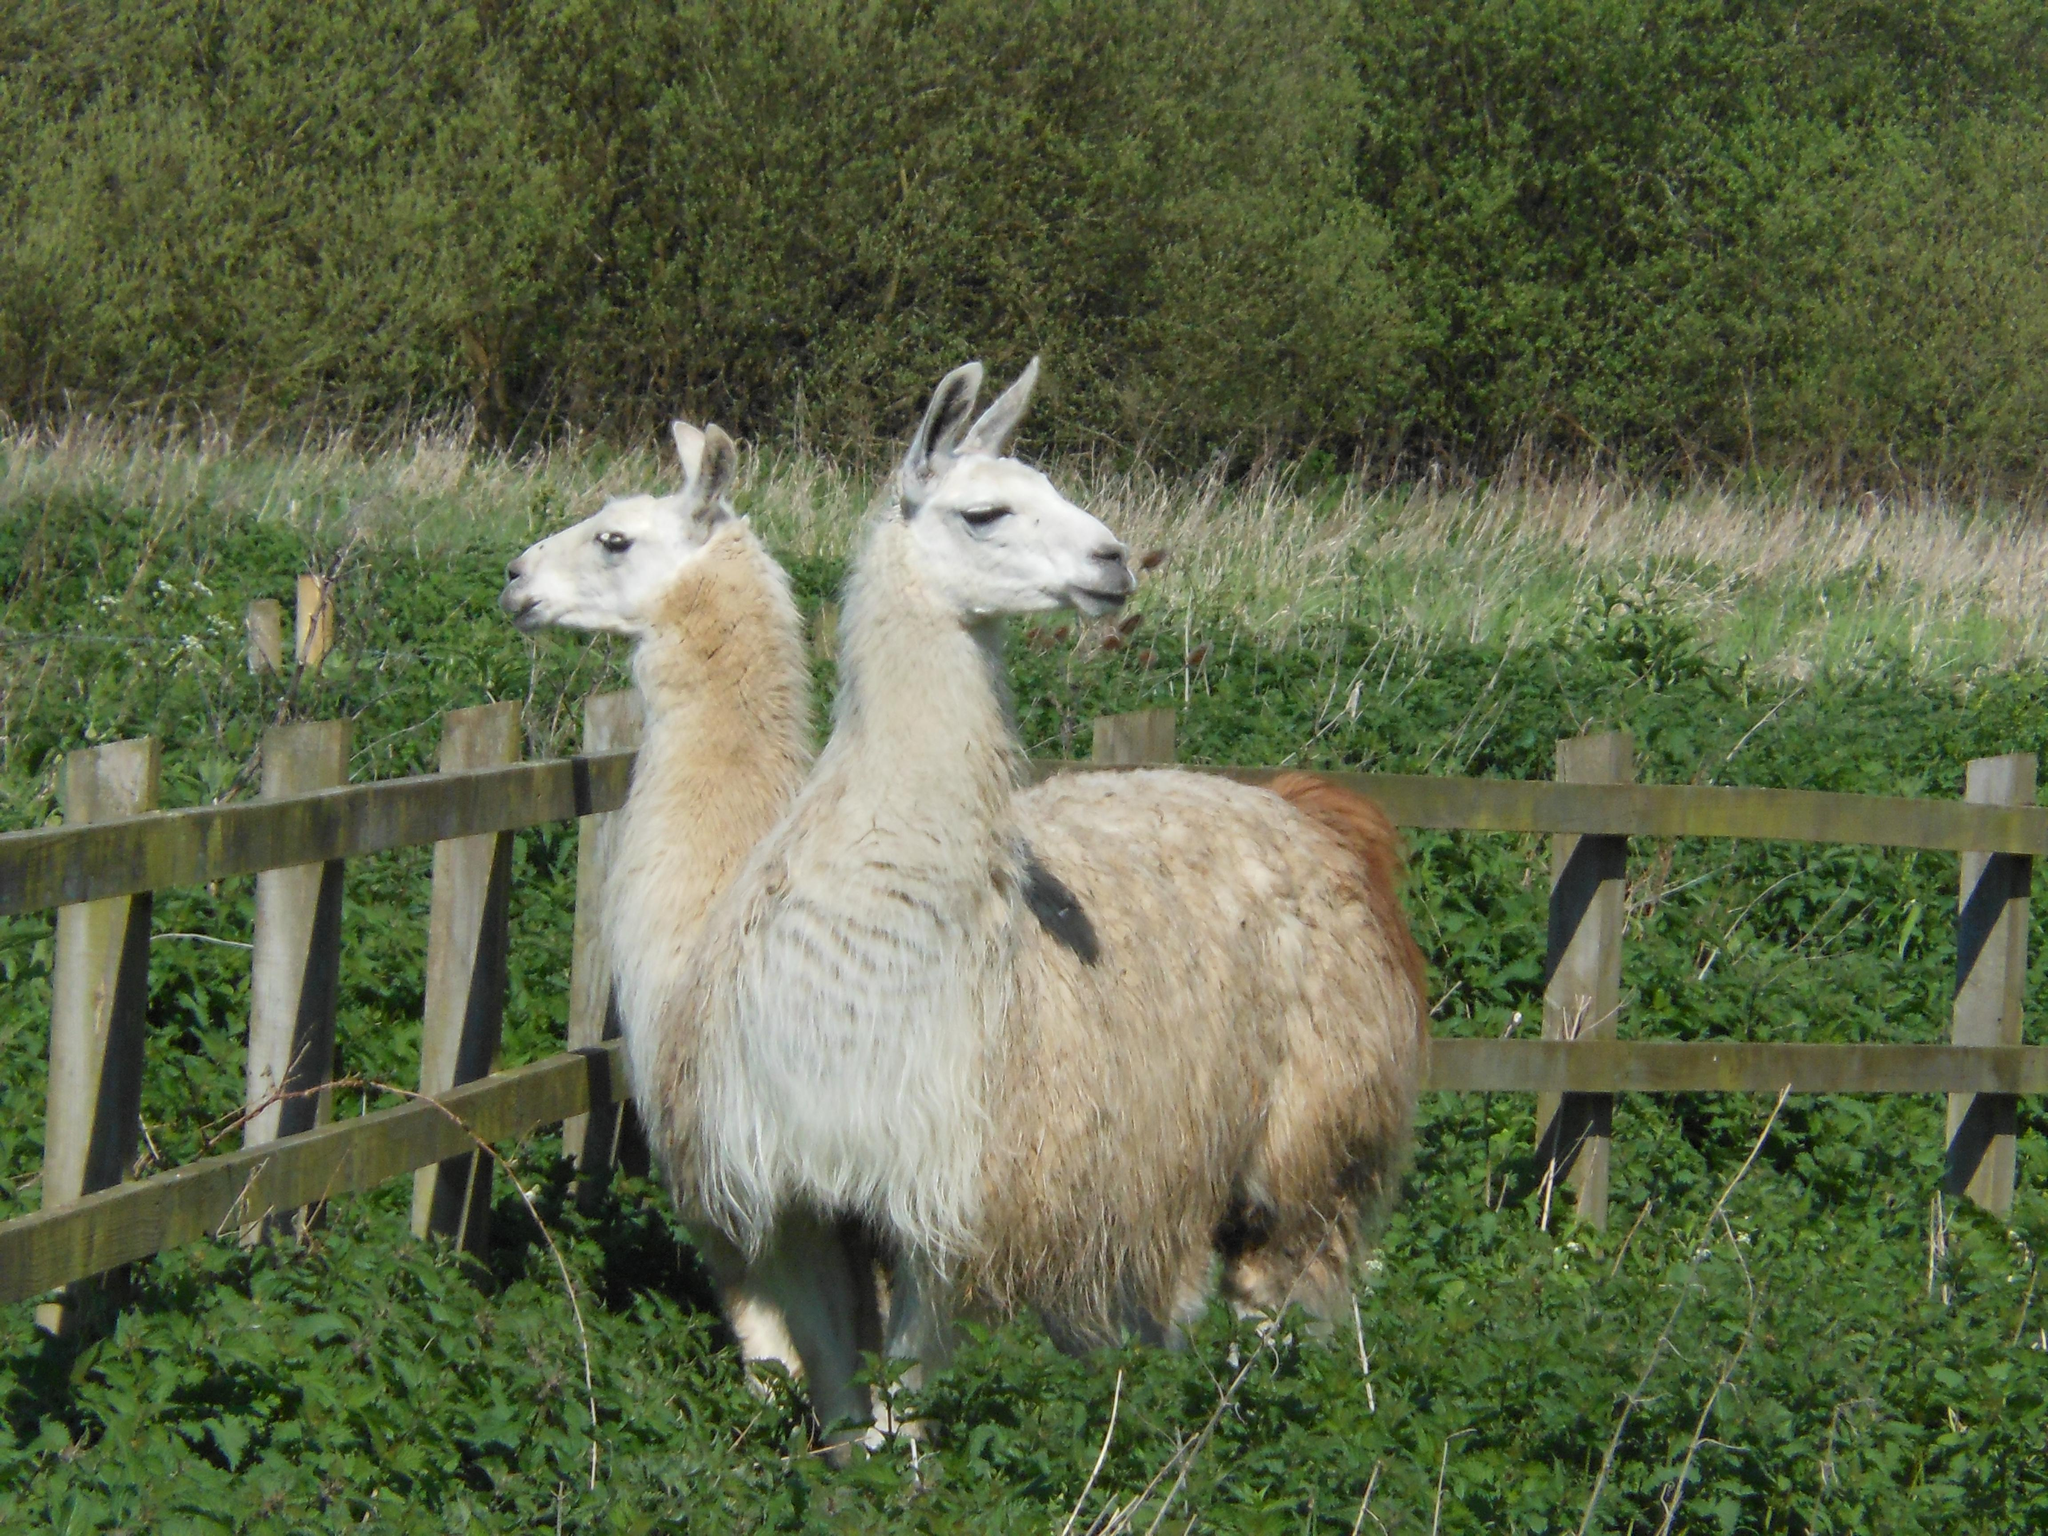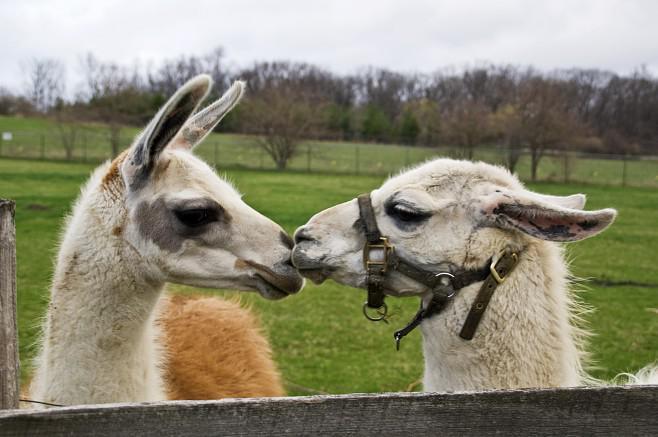The first image is the image on the left, the second image is the image on the right. Evaluate the accuracy of this statement regarding the images: "The llamas in the left image are looking in opposite directions.". Is it true? Answer yes or no. Yes. 